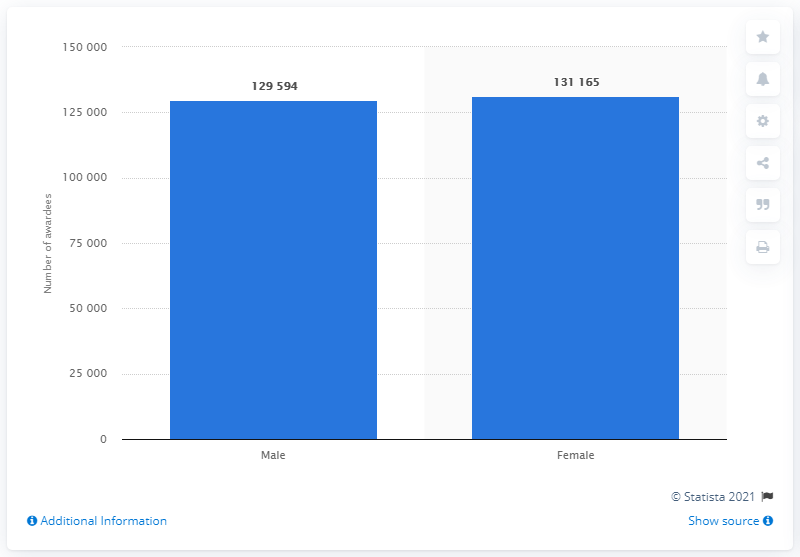Identify some key points in this picture. In 2019, a total of 131,165 female students were awarded their undergraduate degrees in Andhra Pradesh. 